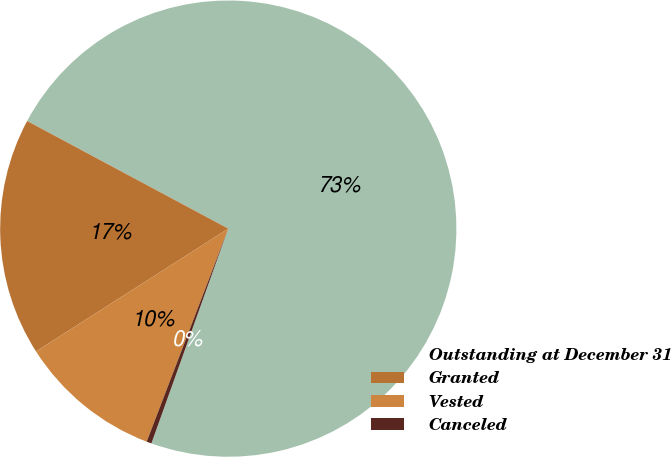<chart> <loc_0><loc_0><loc_500><loc_500><pie_chart><fcel>Outstanding at December 31<fcel>Granted<fcel>Vested<fcel>Canceled<nl><fcel>72.65%<fcel>16.87%<fcel>10.13%<fcel>0.35%<nl></chart> 